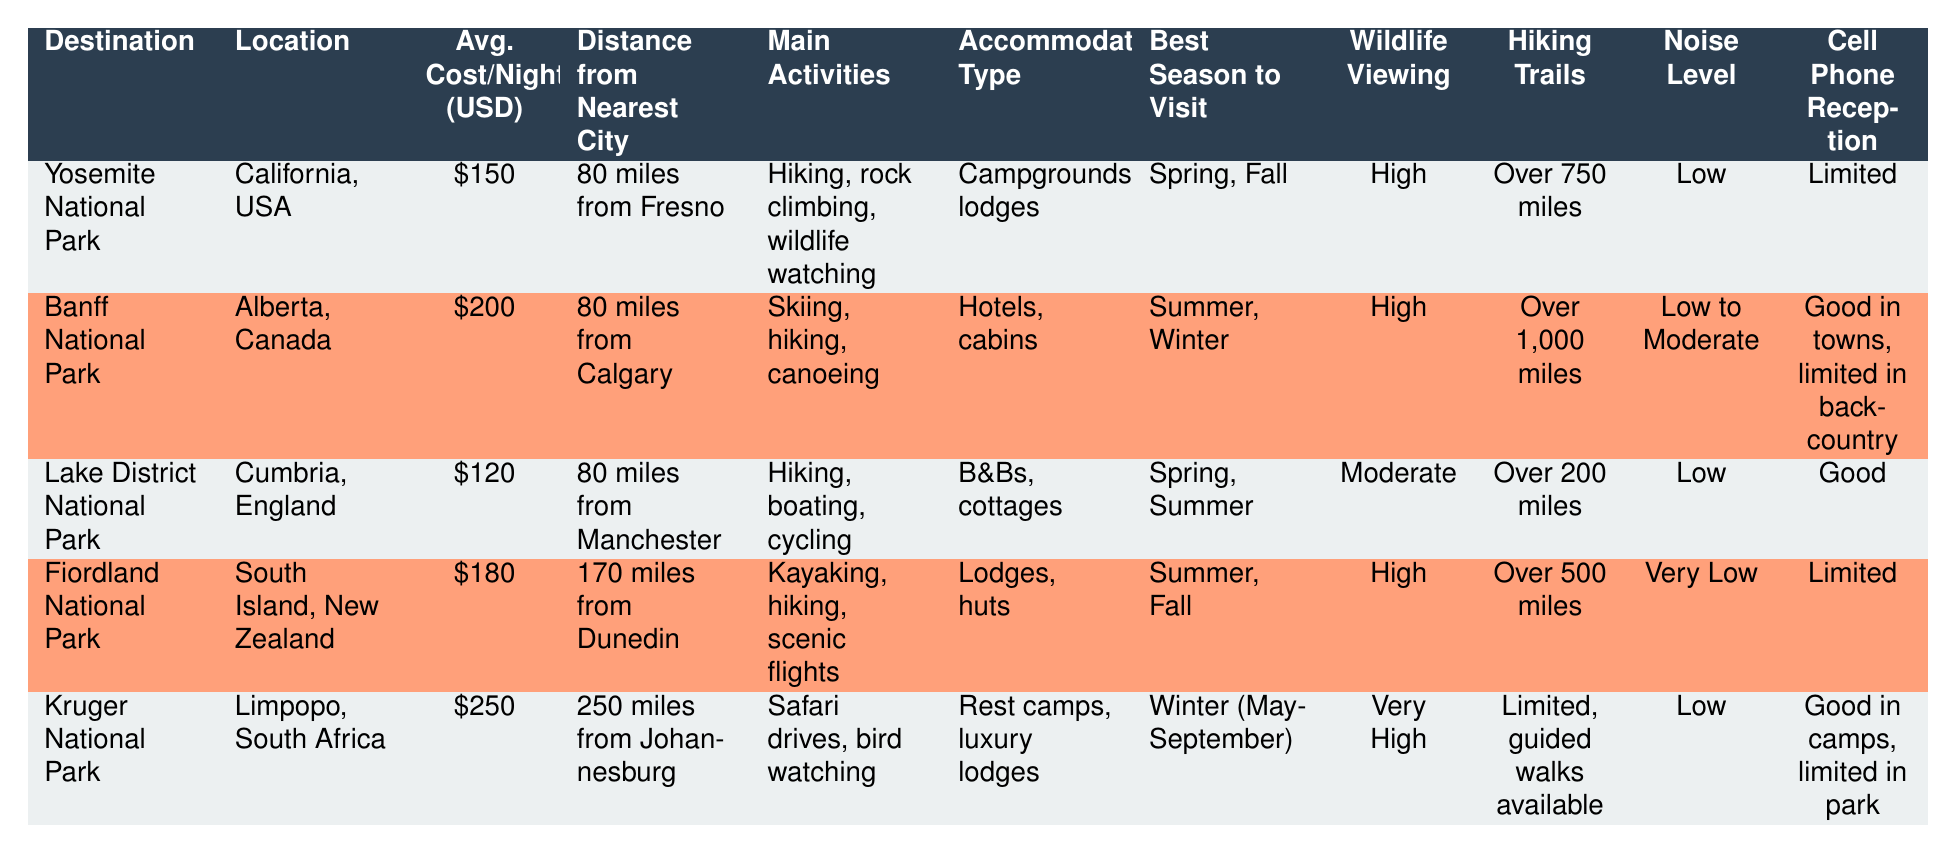What is the average cost per night for staying in Lake District National Park? The table shows that the average cost per night in Lake District National Park is 120 USD.
Answer: 120 USD Which destination has the longest hiking trails? According to the table, Banff National Park has over 1,000 miles of hiking trails, which is more than any other listed destination.
Answer: Banff National Park Is cell phone reception limited in all destinations? The table indicates that cell phone reception is limited in Yosemite National Park, Fiordland National Park, and partially in Kruger National Park (limited in the park), while the other destinations have good reception.
Answer: No Which destinations offer high wildlife viewing opportunities? The table lists wildlife viewing opportunities as high in Yosemite National Park, Banff National Park, and Fiordland National Park, while Kruger National Park has very high wildlife opportunities.
Answer: Yosemite, Banff, Fiordland, and Kruger National Parks What is the total average cost per night for staying at Yosemite, Fiordland, and Lake District National Parks combined? The average costs per night are 150 USD for Yosemite, 180 USD for Fiordland, and 120 USD for Lake District. Adding them up: 150 + 180 + 120 = 450 USD. Hence, the total is 450 USD.
Answer: 450 USD Which destinations have a noise level classified as low? The table shows that Yosemite National Park, Lake District National Park, and Kruger National Park all have a noise level classified as low.
Answer: Yosemite, Lake District, and Kruger National Parks Is Kruger National Park the only destination that has luxury lodges as accommodation? Looking at the table, it shows that Kruger National Park has luxury lodges, while other destinations offer accommodations like campgrounds, lodges, hotels, and cabins, but none are specifically labeled as luxury lodges besides Kruger.
Answer: Yes What is the distance from the nearest city to Fiordland National Park compared to that of Kruger National Park? The table indicates that Fiordland National Park is 170 miles from Dunedin, while Kruger National Park is located 250 miles from Johannesburg. Since 250 miles is greater than 170 miles, Fiordland is closer to its nearest city than Kruger.
Answer: Fiordland is closer 